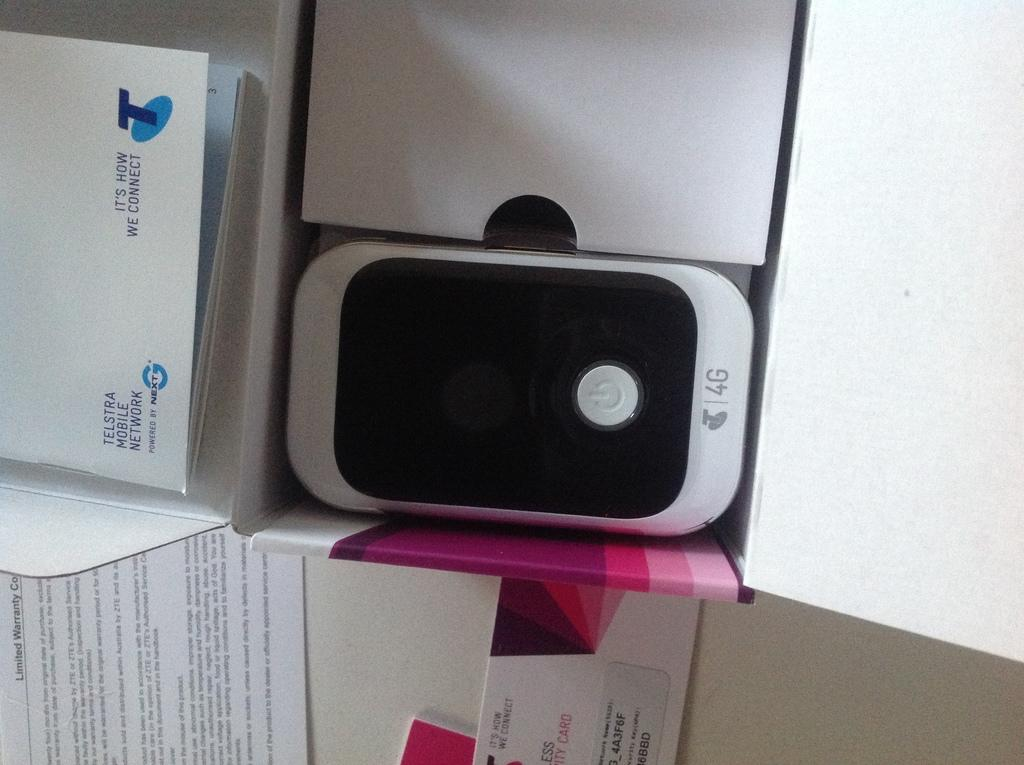What object is present in the image that can hold items? There is a box in the image that can hold items. What specific item can be found inside the box? A mobile phone is inside the box. What else can be seen in the image besides the box and its contents? There are books visible in the image. Can you see the cat's ear in the image? There is no cat or ear present in the image. 